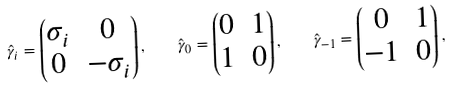<formula> <loc_0><loc_0><loc_500><loc_500>\hat { \gamma } _ { i } = \begin{pmatrix} \sigma _ { i } & 0 \\ 0 & - \sigma _ { i } \end{pmatrix} , \quad \hat { \gamma } _ { 0 } = \begin{pmatrix} 0 & 1 \\ 1 & 0 \end{pmatrix} , \quad \hat { \gamma } _ { - 1 } = \begin{pmatrix} 0 & 1 \\ - 1 & 0 \end{pmatrix} ,</formula> 